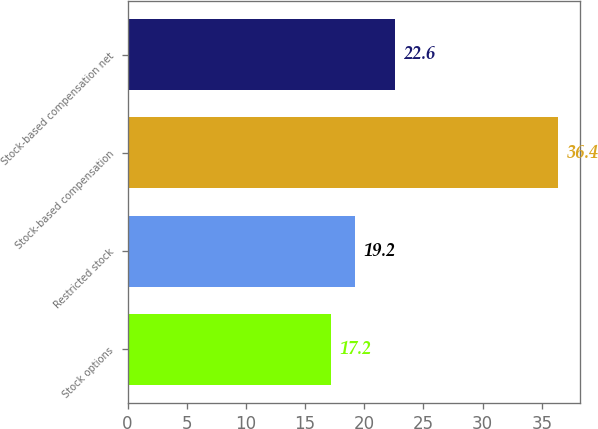<chart> <loc_0><loc_0><loc_500><loc_500><bar_chart><fcel>Stock options<fcel>Restricted stock<fcel>Stock-based compensation<fcel>Stock-based compensation net<nl><fcel>17.2<fcel>19.2<fcel>36.4<fcel>22.6<nl></chart> 